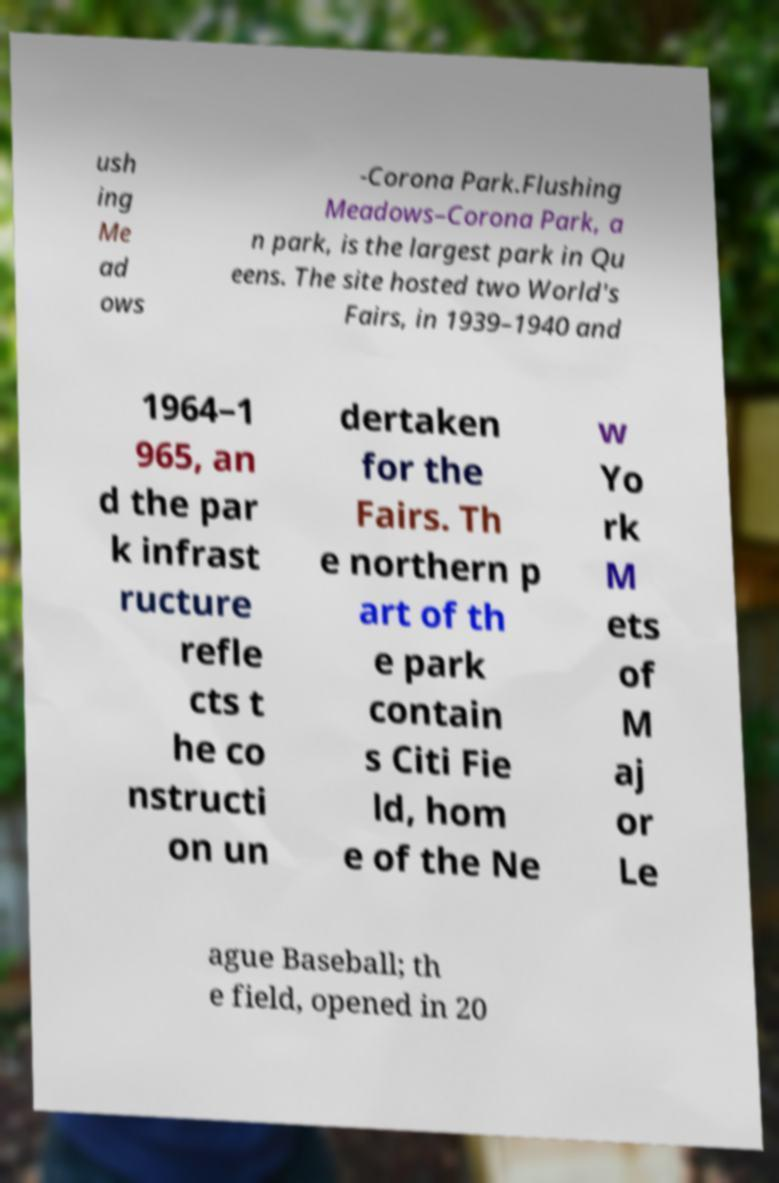Can you accurately transcribe the text from the provided image for me? ush ing Me ad ows -Corona Park.Flushing Meadows–Corona Park, a n park, is the largest park in Qu eens. The site hosted two World's Fairs, in 1939–1940 and 1964–1 965, an d the par k infrast ructure refle cts t he co nstructi on un dertaken for the Fairs. Th e northern p art of th e park contain s Citi Fie ld, hom e of the Ne w Yo rk M ets of M aj or Le ague Baseball; th e field, opened in 20 